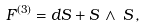Convert formula to latex. <formula><loc_0><loc_0><loc_500><loc_500>F ^ { ( 3 ) } = d S + S \, \wedge \, S \, ,</formula> 